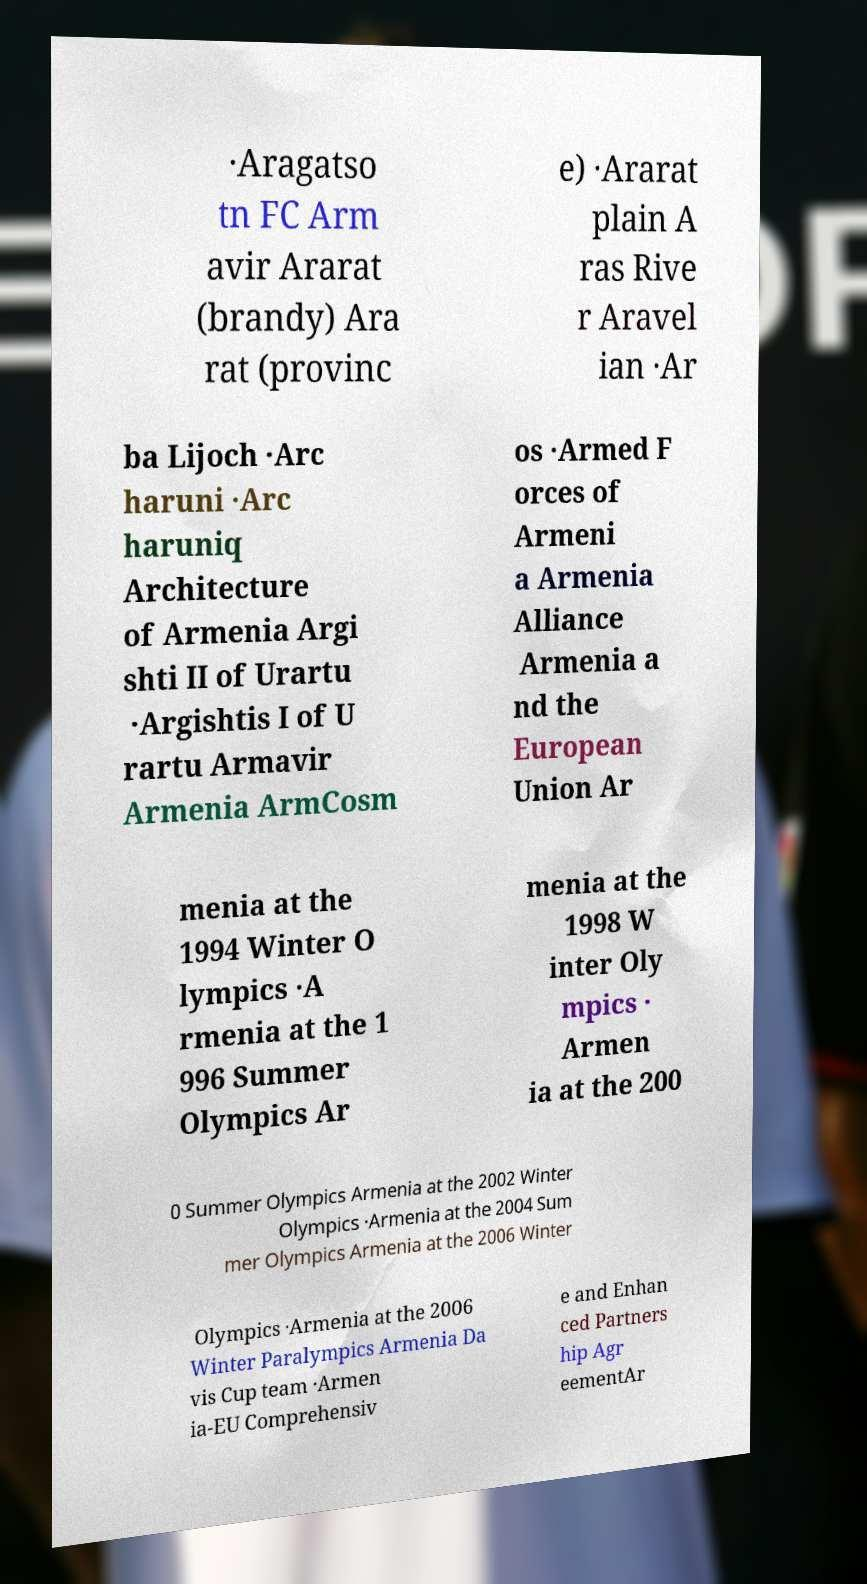Please read and relay the text visible in this image. What does it say? ·Aragatso tn FC Arm avir Ararat (brandy) Ara rat (provinc e) ·Ararat plain A ras Rive r Aravel ian ·Ar ba Lijoch ·Arc haruni ·Arc haruniq Architecture of Armenia Argi shti II of Urartu ·Argishtis I of U rartu Armavir Armenia ArmCosm os ·Armed F orces of Armeni a Armenia Alliance Armenia a nd the European Union Ar menia at the 1994 Winter O lympics ·A rmenia at the 1 996 Summer Olympics Ar menia at the 1998 W inter Oly mpics · Armen ia at the 200 0 Summer Olympics Armenia at the 2002 Winter Olympics ·Armenia at the 2004 Sum mer Olympics Armenia at the 2006 Winter Olympics ·Armenia at the 2006 Winter Paralympics Armenia Da vis Cup team ·Armen ia-EU Comprehensiv e and Enhan ced Partners hip Agr eementAr 